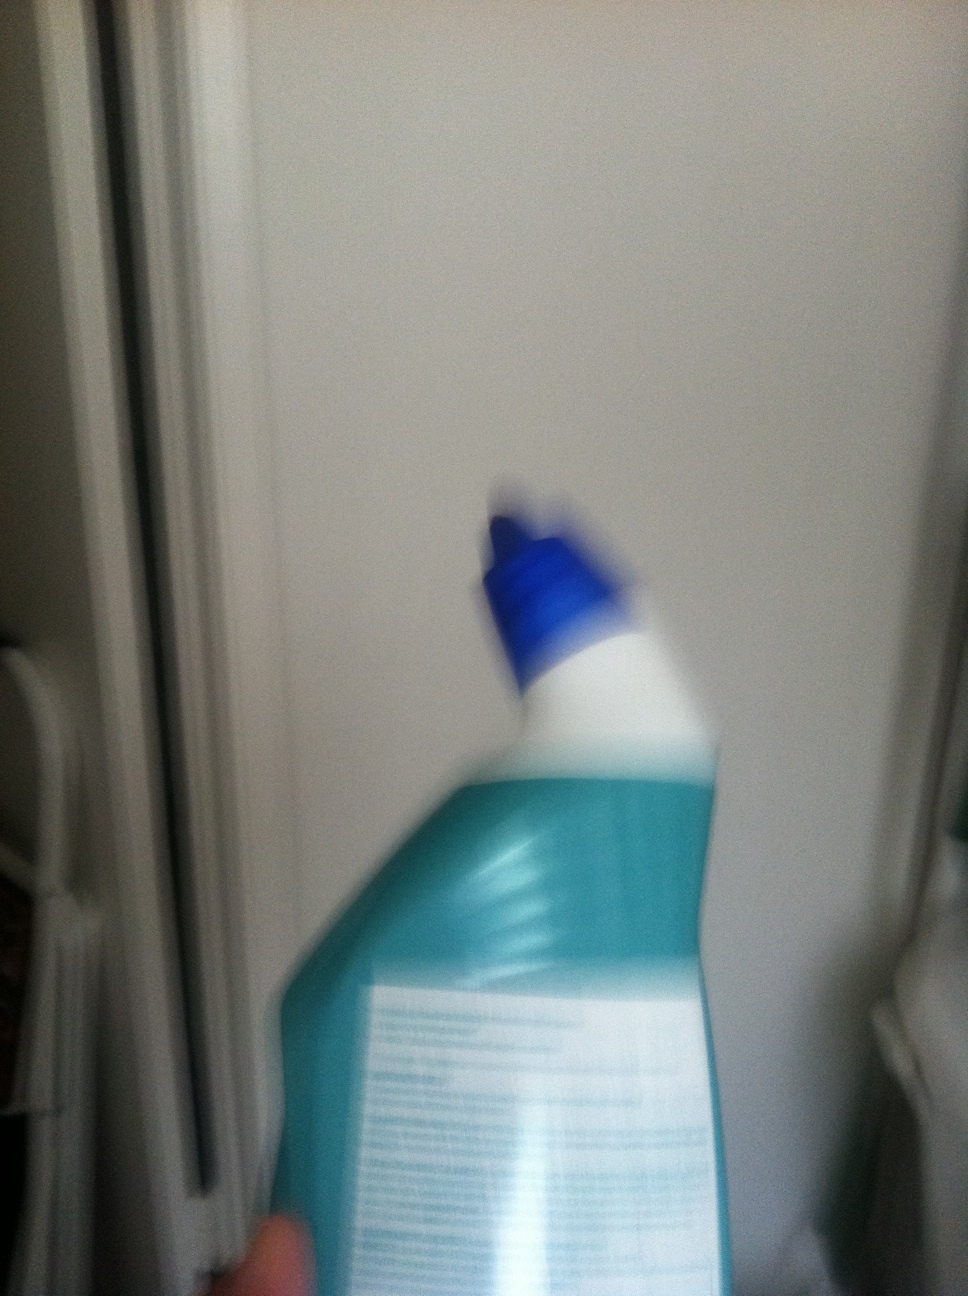What could be the significance of the blue cap on this bottle? The blue cap can be designed to easily identify the nature of the contents, which might be for a specific type of cleaning like glass or surfaces, or it might represent branding of the product. 